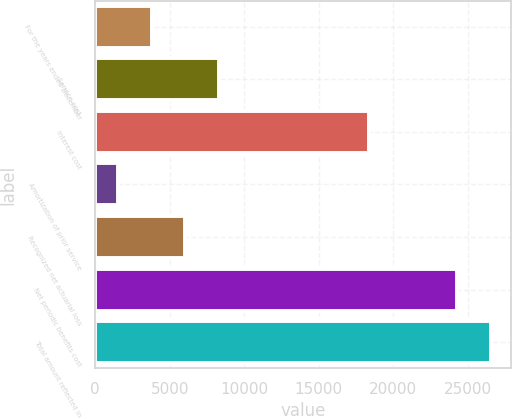Convert chart to OTSL. <chart><loc_0><loc_0><loc_500><loc_500><bar_chart><fcel>For the years ended December<fcel>Service cost<fcel>Interest cost<fcel>Amortization of prior service<fcel>Recognized net actuarial loss<fcel>Net periodic benefits cost<fcel>Total amount reflected in<nl><fcel>3784.3<fcel>8338.9<fcel>18335<fcel>1507<fcel>6061.6<fcel>24280<fcel>26557.3<nl></chart> 